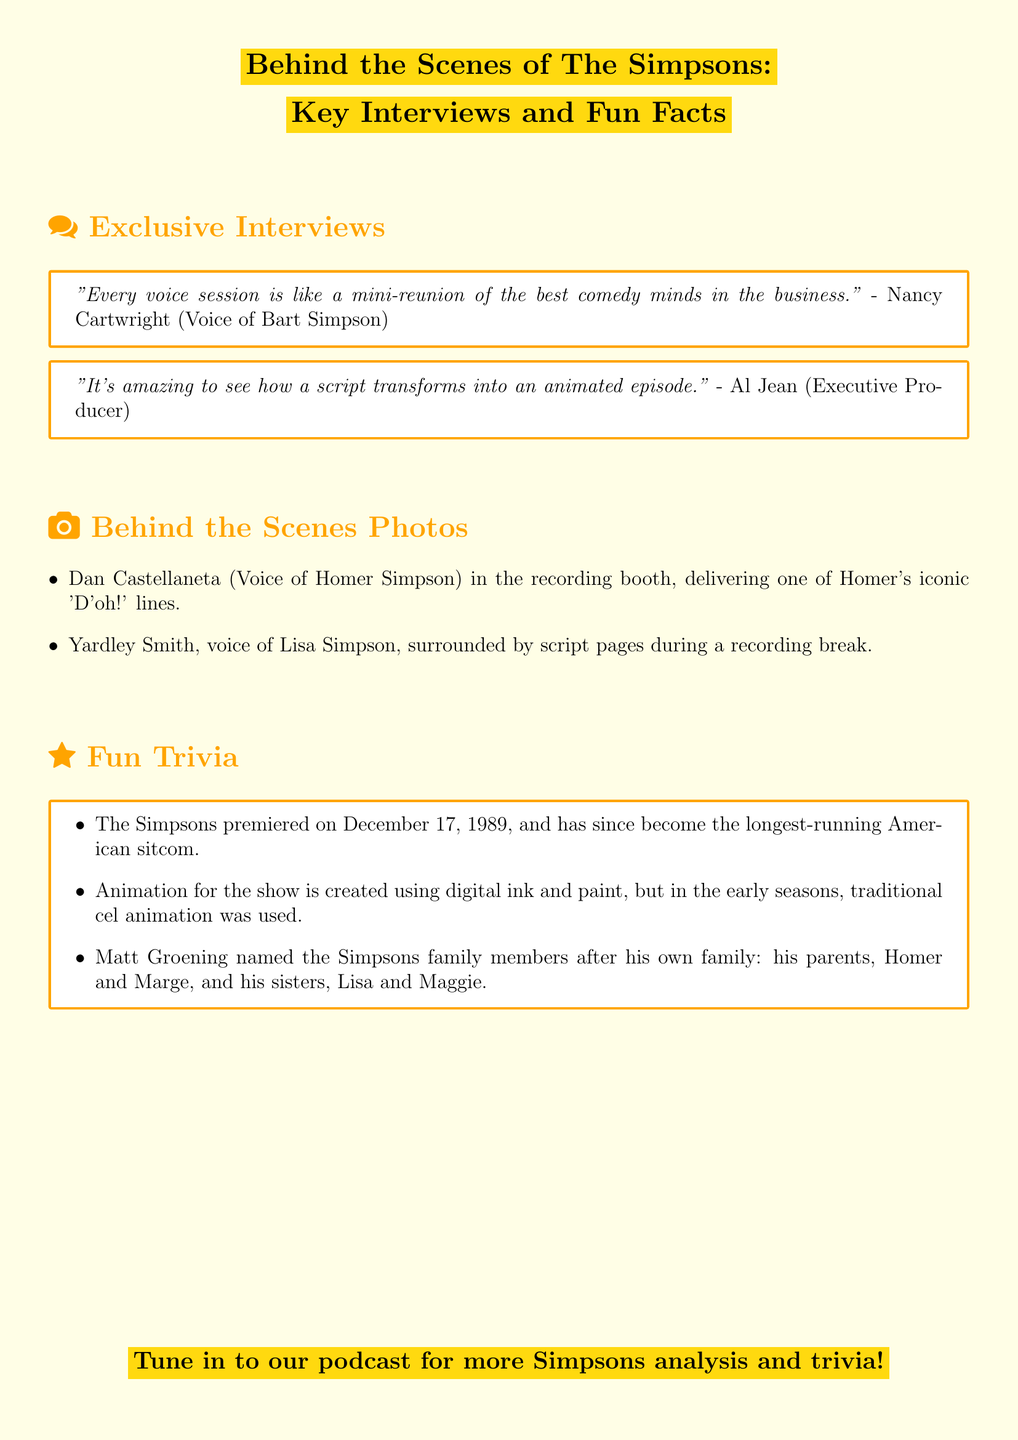What is the premiere date of The Simpsons? The premiere date of The Simpsons is mentioned in the trivia section of the document.
Answer: December 17, 1989 Who is the voice of Bart Simpson? The document includes quotes from cast members, and Nancy Cartwright voices Bart Simpson.
Answer: Nancy Cartwright Which production role does Al Jean hold? Al Jean is identified in the document as the Executive Producer.
Answer: Executive Producer How is the animation for the show created? The trivia section describes the animation techniques used for The Simpsons.
Answer: Digital ink and paint What was used for animation in the early seasons? The document contrasts the animation techniques from the early seasons to the current method.
Answer: Traditional cel animation Which family member is named after Matt Groening's mother? The document states that family members were named after his own family, specifying names.
Answer: Marge What is unique about the voice sessions according to Nancy Cartwright? A quote from Nancy Cartwright highlights the nature of the voice sessions.
Answer: Mini-reunion Who is surrounded by script pages during a recording break? The behind-the-scenes photos section mentions this detail about the voice actor.
Answer: Yardley Smith 